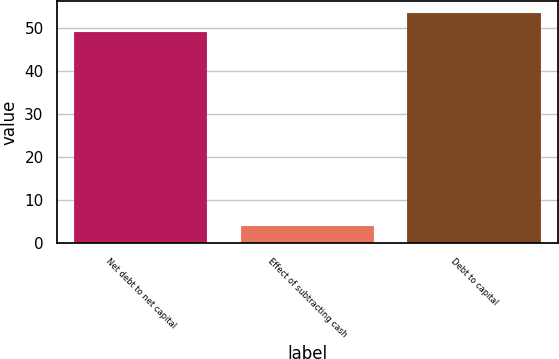Convert chart. <chart><loc_0><loc_0><loc_500><loc_500><bar_chart><fcel>Net debt to net capital<fcel>Effect of subtracting cash<fcel>Debt to capital<nl><fcel>49<fcel>4.09<fcel>53.49<nl></chart> 